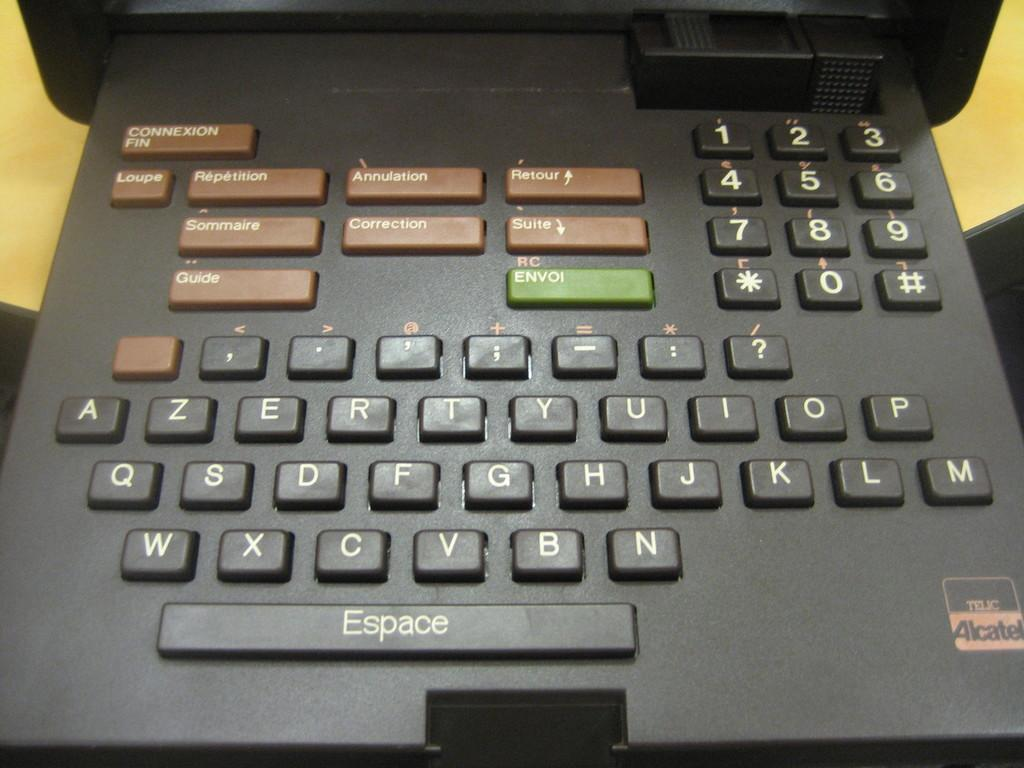<image>
Present a compact description of the photo's key features. An odd keyboard for a device by Telic Alcatel. 